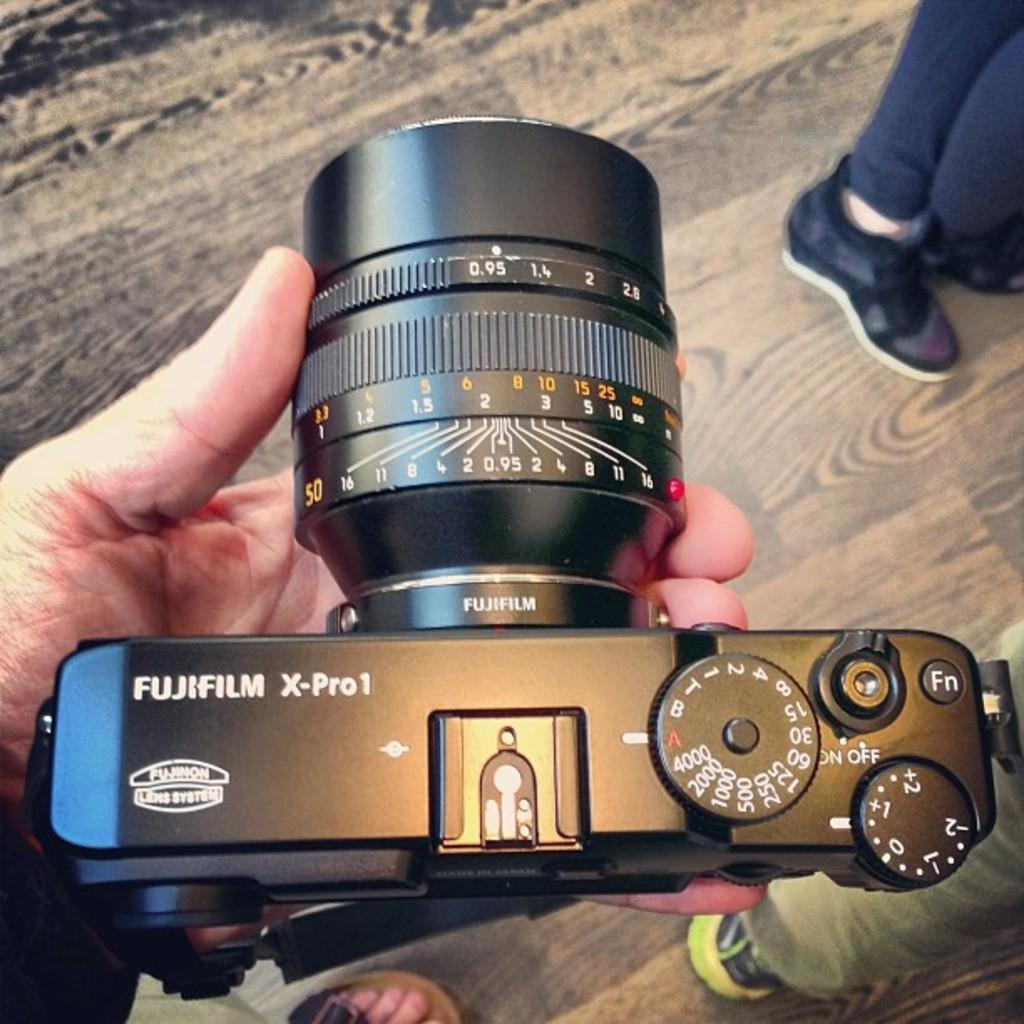How many people are in the image? There are a few people in the image. What can be observed about the people's appearance? The people are partially covered. Can you identify any specific activity being performed by one of the people? Yes, there is a person holding a camera in the image. What type of surface can be seen beneath the people? The ground is visible in the image. What type of scarf is the tiger wearing in the image? There is no tiger or scarf present in the image. What wish does the person holding the camera have while taking the photo? We cannot determine the person's wishes from the image alone. 